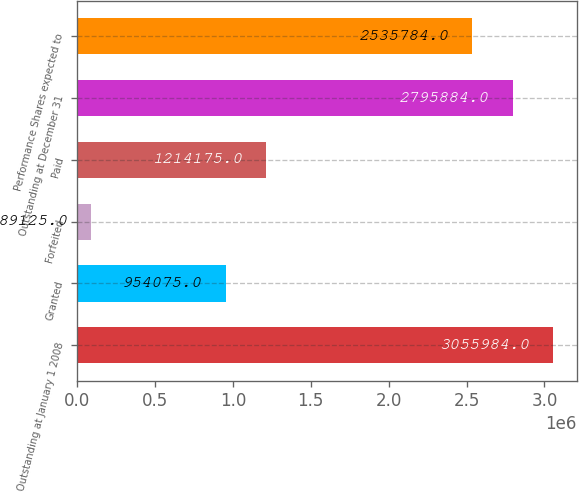Convert chart to OTSL. <chart><loc_0><loc_0><loc_500><loc_500><bar_chart><fcel>Outstanding at January 1 2008<fcel>Granted<fcel>Forfeited<fcel>Paid<fcel>Outstanding at December 31<fcel>Performance Shares expected to<nl><fcel>3.05598e+06<fcel>954075<fcel>89125<fcel>1.21418e+06<fcel>2.79588e+06<fcel>2.53578e+06<nl></chart> 